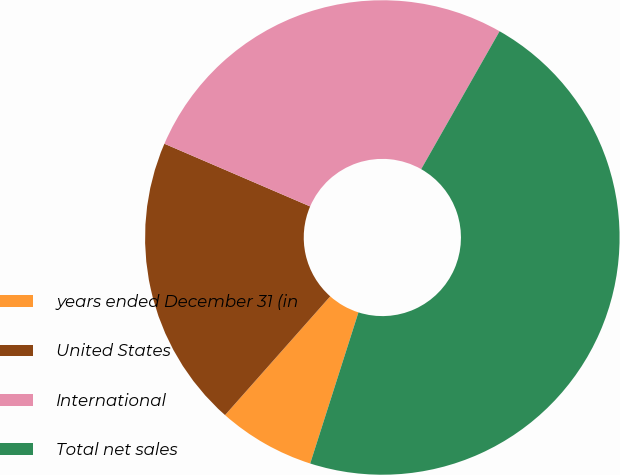<chart> <loc_0><loc_0><loc_500><loc_500><pie_chart><fcel>years ended December 31 (in<fcel>United States<fcel>International<fcel>Total net sales<nl><fcel>6.62%<fcel>19.93%<fcel>26.76%<fcel>46.69%<nl></chart> 